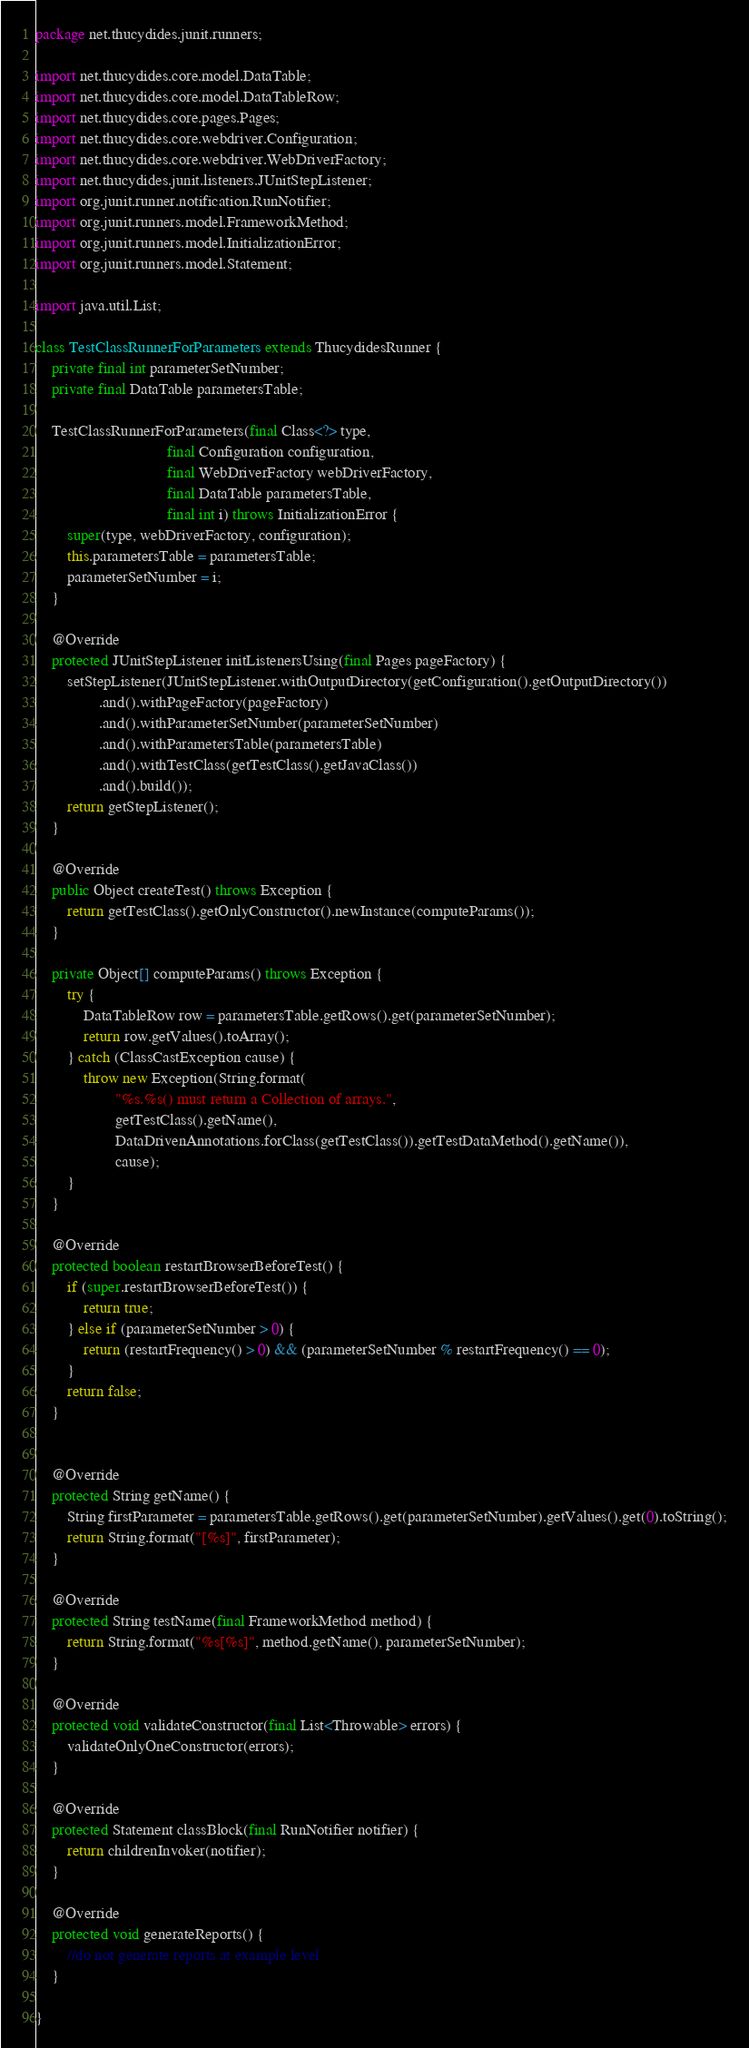<code> <loc_0><loc_0><loc_500><loc_500><_Java_>package net.thucydides.junit.runners;

import net.thucydides.core.model.DataTable;
import net.thucydides.core.model.DataTableRow;
import net.thucydides.core.pages.Pages;
import net.thucydides.core.webdriver.Configuration;
import net.thucydides.core.webdriver.WebDriverFactory;
import net.thucydides.junit.listeners.JUnitStepListener;
import org.junit.runner.notification.RunNotifier;
import org.junit.runners.model.FrameworkMethod;
import org.junit.runners.model.InitializationError;
import org.junit.runners.model.Statement;

import java.util.List;

class TestClassRunnerForParameters extends ThucydidesRunner {
    private final int parameterSetNumber;
    private final DataTable parametersTable;

    TestClassRunnerForParameters(final Class<?> type,
                                 final Configuration configuration,
                                 final WebDriverFactory webDriverFactory,
                                 final DataTable parametersTable,
                                 final int i) throws InitializationError {
        super(type, webDriverFactory, configuration);
        this.parametersTable = parametersTable;
        parameterSetNumber = i;
    }

    @Override
    protected JUnitStepListener initListenersUsing(final Pages pageFactory) {
        setStepListener(JUnitStepListener.withOutputDirectory(getConfiguration().getOutputDirectory())
                .and().withPageFactory(pageFactory)
                .and().withParameterSetNumber(parameterSetNumber)
                .and().withParametersTable(parametersTable)
                .and().withTestClass(getTestClass().getJavaClass())
                .and().build());
        return getStepListener();
    }

    @Override
    public Object createTest() throws Exception {
        return getTestClass().getOnlyConstructor().newInstance(computeParams());
    }

    private Object[] computeParams() throws Exception {
        try {
            DataTableRow row = parametersTable.getRows().get(parameterSetNumber);
            return row.getValues().toArray();
        } catch (ClassCastException cause) {
            throw new Exception(String.format(
                    "%s.%s() must return a Collection of arrays.",
                    getTestClass().getName(),
                    DataDrivenAnnotations.forClass(getTestClass()).getTestDataMethod().getName()),
                    cause);
        }
    }

    @Override
    protected boolean restartBrowserBeforeTest() {
        if (super.restartBrowserBeforeTest()) {
            return true;
        } else if (parameterSetNumber > 0) {
            return (restartFrequency() > 0) && (parameterSetNumber % restartFrequency() == 0);
        }
        return false;
    }


    @Override
    protected String getName() {
        String firstParameter = parametersTable.getRows().get(parameterSetNumber).getValues().get(0).toString();
        return String.format("[%s]", firstParameter);
    }

    @Override
    protected String testName(final FrameworkMethod method) {
        return String.format("%s[%s]", method.getName(), parameterSetNumber);
    }

    @Override
    protected void validateConstructor(final List<Throwable> errors) {
        validateOnlyOneConstructor(errors);
    }

    @Override
    protected Statement classBlock(final RunNotifier notifier) {
        return childrenInvoker(notifier);
    }

    @Override
    protected void generateReports() {
        //do not generate reports at example level
    }

}
</code> 